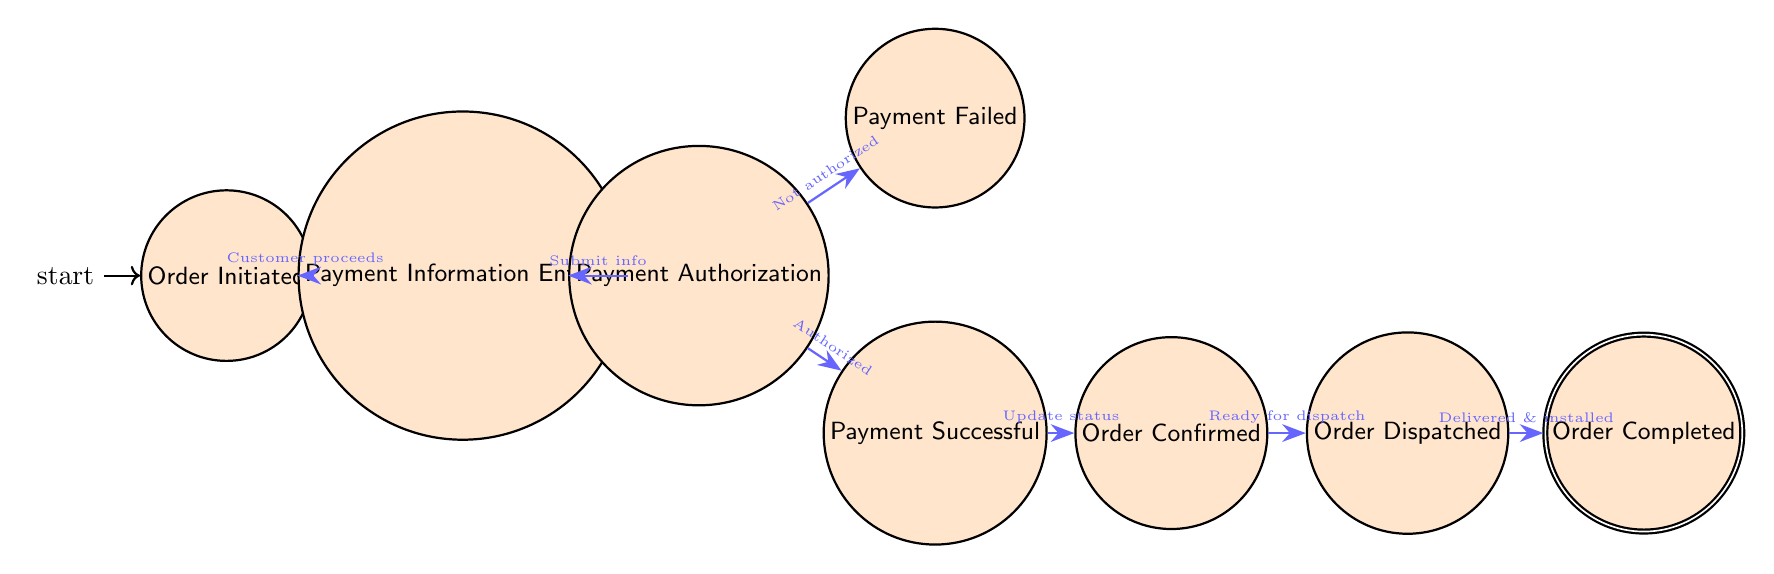What is the initial state in the payment processing diagram? The initial state is the first node in the diagram, labeled "Order Initiated". This is where the process begins when the customer selects the solar equipment and initiates the order.
Answer: Order Initiated How many states are there in the diagram? Counting all distinct nodes in the diagram, there are eight states: Order Initiated, Payment Information Entered, Payment Authorization, Payment Successful, Payment Failed, Order Confirmed, Order Dispatched, and Order Completed.
Answer: Eight Which state follows "Payment Authorization" if payment is not authorized? From the "Payment Authorization" state, if payment is not authorized, the transition goes to the state labeled "Payment Failed". This indicates that the payment process has encountered an issue.
Answer: Payment Failed What condition leads from "Payment Successful" to "Order Confirmed"? The transition from "Payment Successful" to "Order Confirmed" occurs under the condition that the system updates the order status after the successful payment. Thus, the order can be confirmed.
Answer: System updates order status If an order is confirmed, what is the next state? After the order is confirmed, the next state is "Order Dispatched" which follows when the solar equipment is ready for dispatch. This indicates progress in the order fulfillment process.
Answer: Order Dispatched What happens if the customer proceeds to payment from "Order Initiated"? When the customer proceeds to payment from "Order Initiated", the next state in the process is "Payment Information Entered," indicating that the customer is now entering their payment details.
Answer: Payment Information Entered How does the process end? The process concludes when the last state "Order Completed" is reached, which signifies that the order has been successfully delivered and installation of the solar equipment is complete.
Answer: Order Completed What are the possible outcomes from the "Payment Authorization" state? From the "Payment Authorization" state, there are two possible outcomes based on payment status: if authorized, it transitions to "Payment Successful"; if not authorized, it goes to "Payment Failed".
Answer: Payment Successful or Payment Failed 